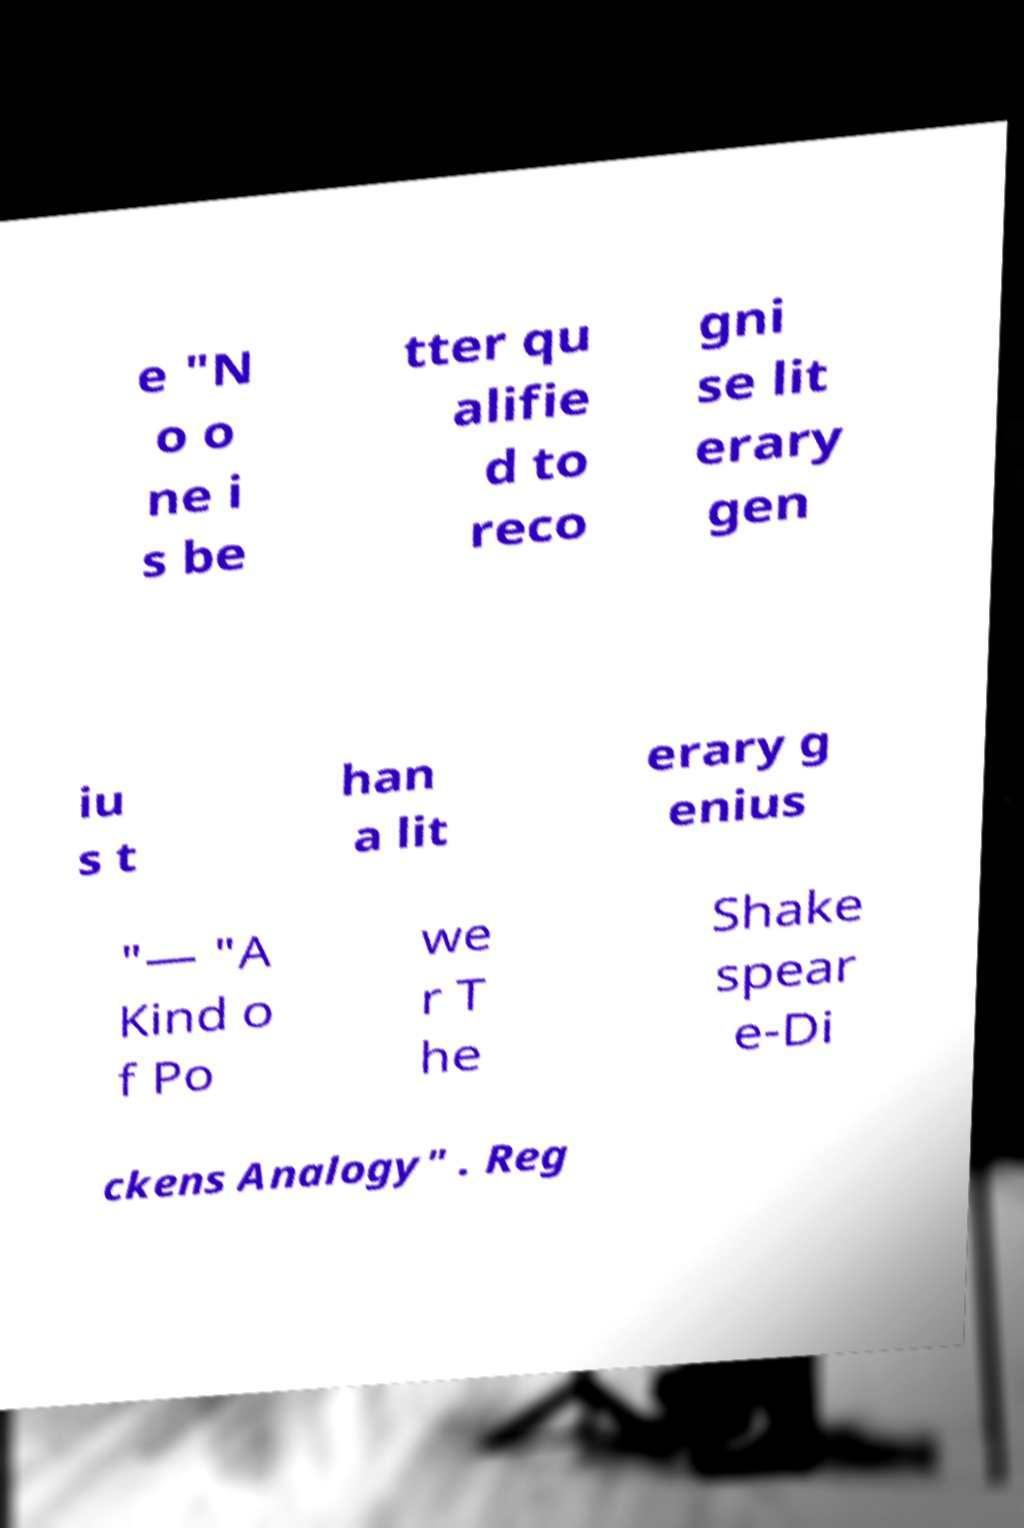What messages or text are displayed in this image? I need them in a readable, typed format. e "N o o ne i s be tter qu alifie d to reco gni se lit erary gen iu s t han a lit erary g enius "— "A Kind o f Po we r T he Shake spear e-Di ckens Analogy" . Reg 